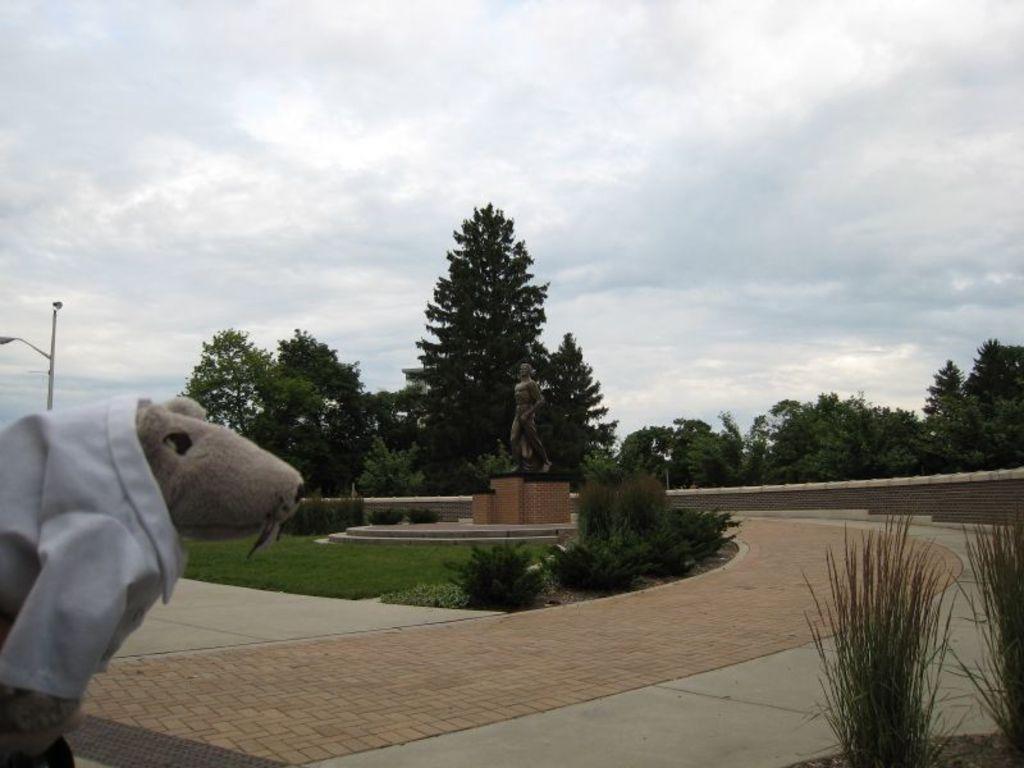Describe this image in one or two sentences. In this image we can see a statue. In front of the statue we can see stairs, grass and few plants. Behind the statue we can see a group of trees. At the top we can see the sky. On the Left side, we can see a toy and a street pole. On the right side, we can see a wall and the grass. 